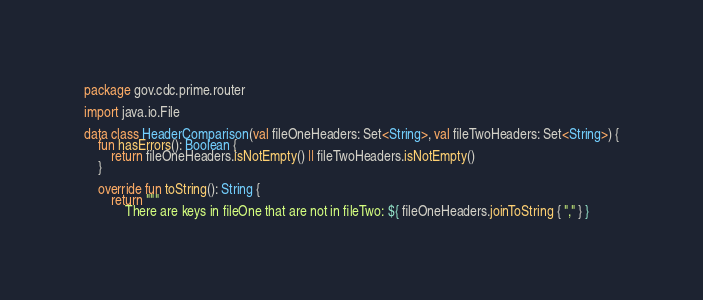Convert code to text. <code><loc_0><loc_0><loc_500><loc_500><_Kotlin_>package gov.cdc.prime.router

import java.io.File

data class HeaderComparison(val fileOneHeaders: Set<String>, val fileTwoHeaders: Set<String>) {
    fun hasErrors(): Boolean {
        return fileOneHeaders.isNotEmpty() || fileTwoHeaders.isNotEmpty()
    }

    override fun toString(): String {
        return """
            There are keys in fileOne that are not in fileTwo: ${ fileOneHeaders.joinToString { "," } }</code> 